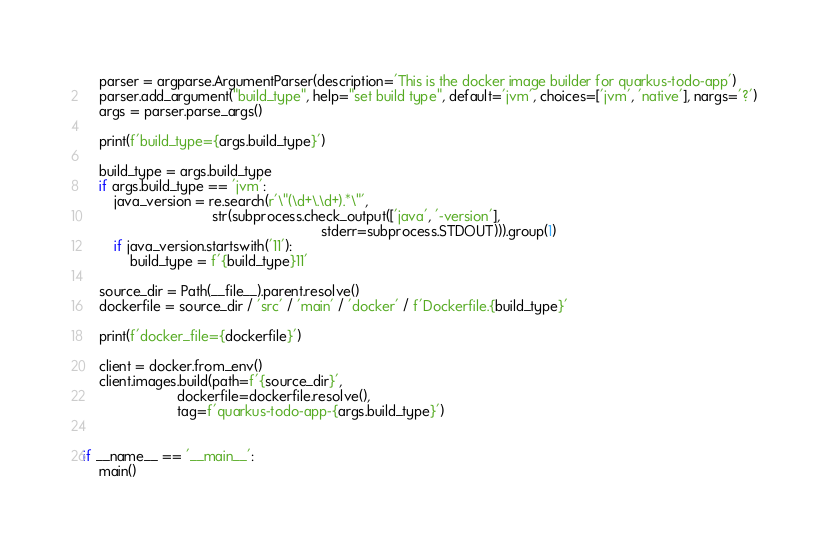Convert code to text. <code><loc_0><loc_0><loc_500><loc_500><_Python_>    parser = argparse.ArgumentParser(description='This is the docker image builder for quarkus-todo-app')
    parser.add_argument("build_type", help="set build type", default='jvm', choices=['jvm', 'native'], nargs='?')
    args = parser.parse_args()

    print(f'build_type={args.build_type}')

    build_type = args.build_type
    if args.build_type == 'jvm':
        java_version = re.search(r'\"(\d+\.\d+).*\"',
                                 str(subprocess.check_output(['java', '-version'],
                                                             stderr=subprocess.STDOUT))).group(1)
        if java_version.startswith('11'):
            build_type = f'{build_type}11'

    source_dir = Path(__file__).parent.resolve()
    dockerfile = source_dir / 'src' / 'main' / 'docker' / f'Dockerfile.{build_type}'

    print(f'docker_file={dockerfile}')

    client = docker.from_env()
    client.images.build(path=f'{source_dir}',
                        dockerfile=dockerfile.resolve(),
                        tag=f'quarkus-todo-app-{args.build_type}')


if __name__ == '__main__':
    main()
</code> 